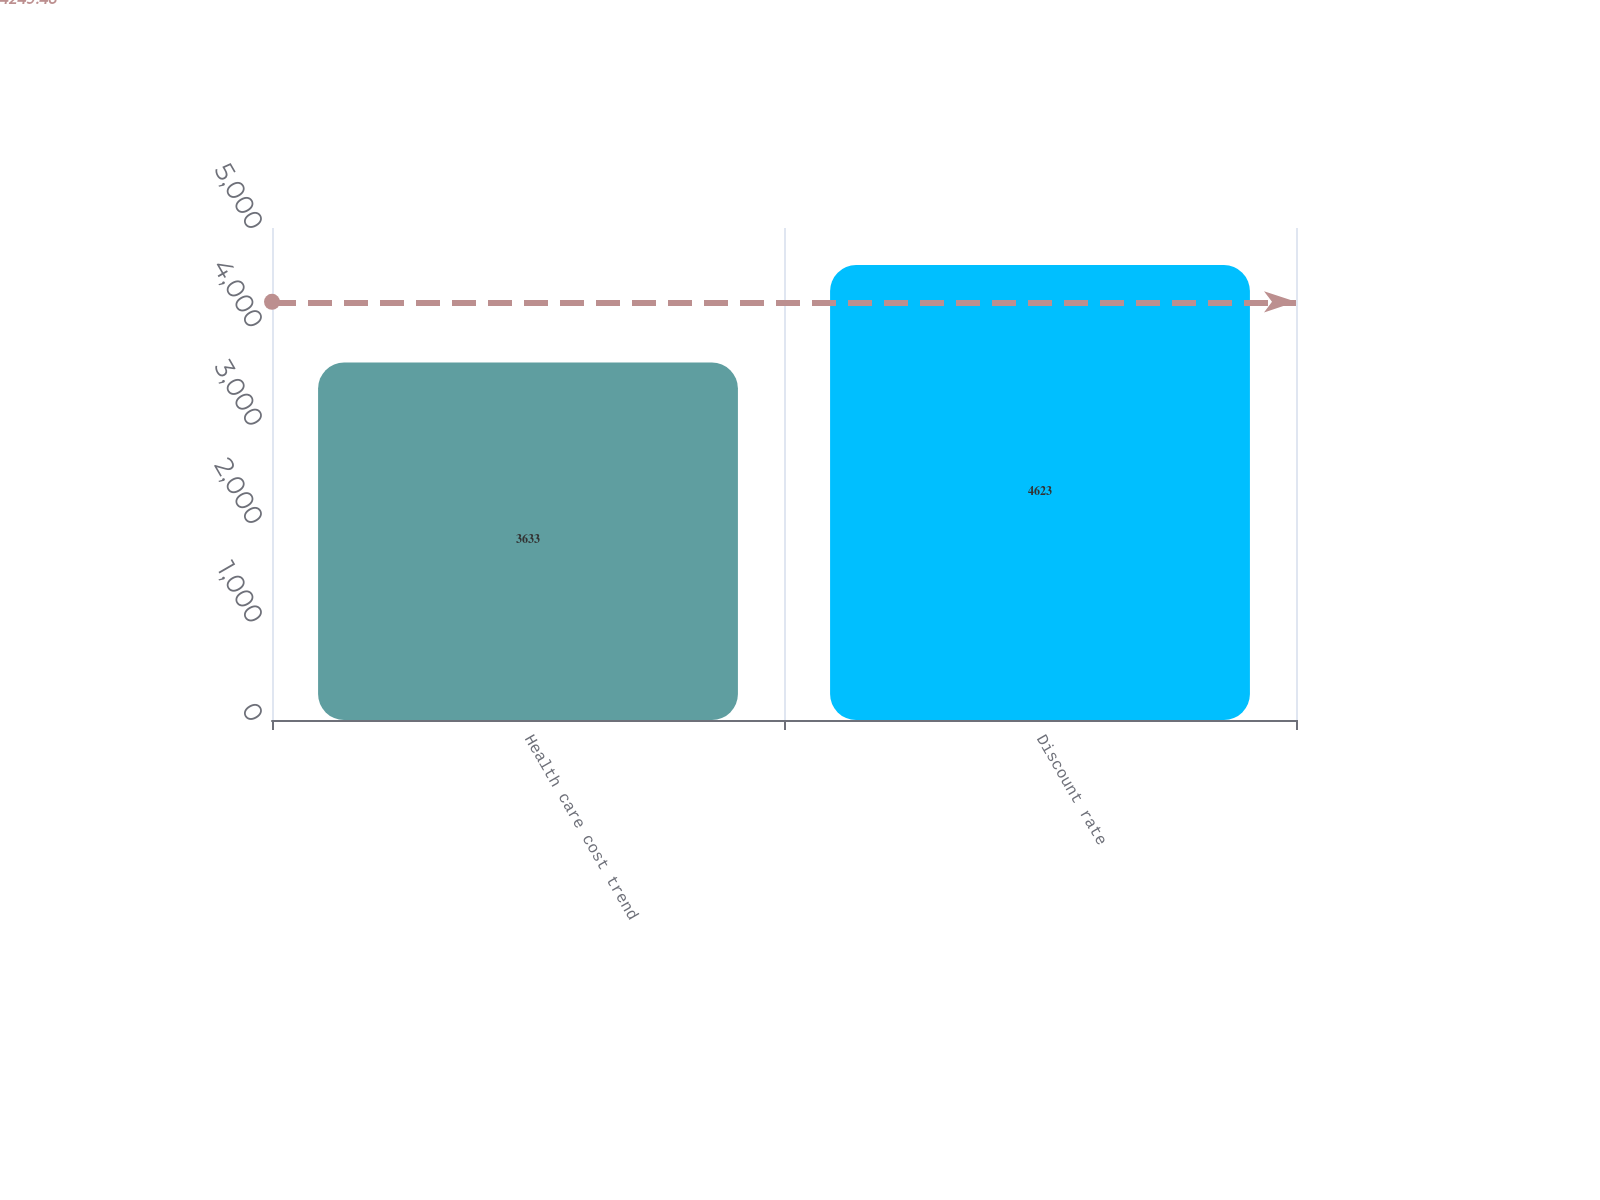Convert chart to OTSL. <chart><loc_0><loc_0><loc_500><loc_500><bar_chart><fcel>Health care cost trend<fcel>Discount rate<nl><fcel>3633<fcel>4623<nl></chart> 